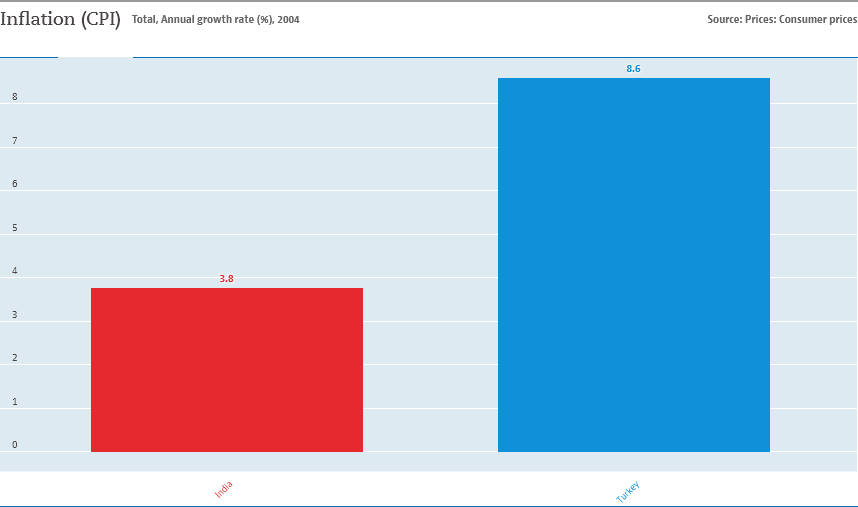Specify some key components in this picture. The graph displays two countries, India and Turkey, and their corresponding values. The value of Turkey is higher than that of India. The color bar in the graph indicates that the value of 3.8 is represented by the color shown for India. 